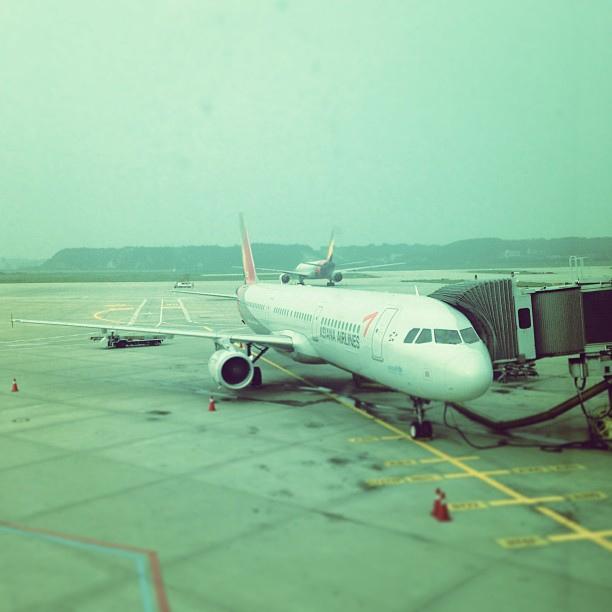What number do you see on the plane?
Concise answer only. 1. Does this plane have propellers or turbines?
Short answer required. Turbines. Is this a bench?
Be succinct. No. What kind of airplane is this?
Give a very brief answer. Jet. Where is this?
Concise answer only. Airport. Is this a passenger plane?
Give a very brief answer. Yes. Does this plane have propellers?
Be succinct. No. What kind of plane is this?
Be succinct. Passenger. 